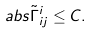Convert formula to latex. <formula><loc_0><loc_0><loc_500><loc_500>\ a b s { \tilde { \Gamma } ^ { i } _ { i j } } \leq C .</formula> 